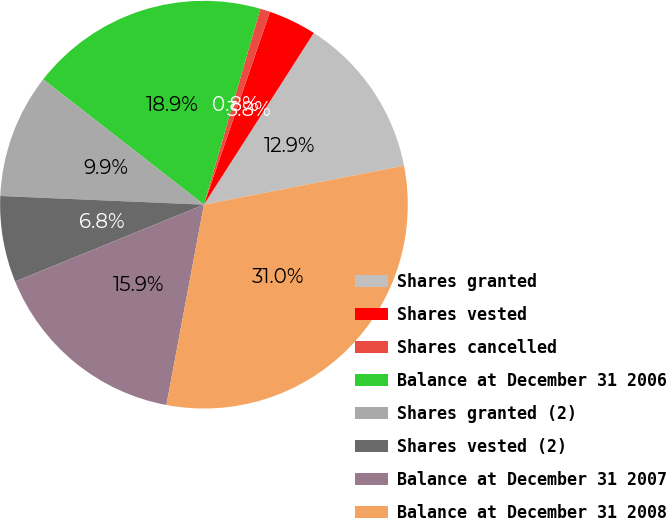<chart> <loc_0><loc_0><loc_500><loc_500><pie_chart><fcel>Shares granted<fcel>Shares vested<fcel>Shares cancelled<fcel>Balance at December 31 2006<fcel>Shares granted (2)<fcel>Shares vested (2)<fcel>Balance at December 31 2007<fcel>Balance at December 31 2008<nl><fcel>12.88%<fcel>3.81%<fcel>0.79%<fcel>18.92%<fcel>9.86%<fcel>6.83%<fcel>15.9%<fcel>31.01%<nl></chart> 